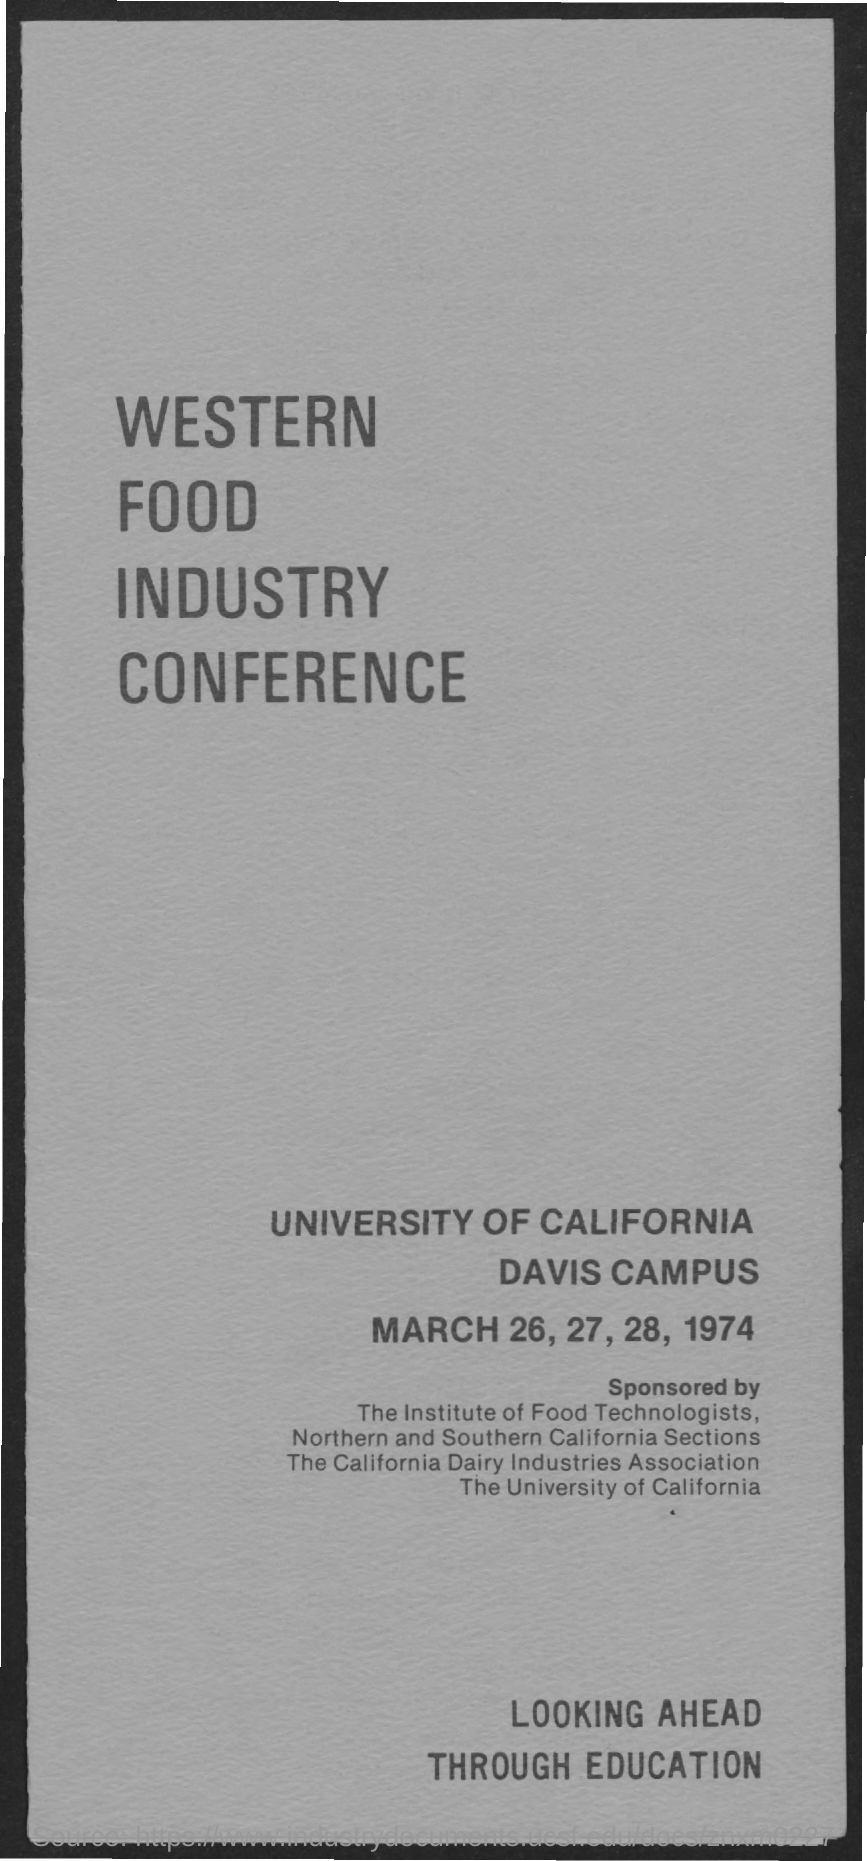Where is the western food industry conference held?
Offer a terse response. UNIVERSITY OF CALIFORNIA, DAVIS CAMPUS. When is the western food industry conference held?
Your response must be concise. March 26, 27, 28, 1974. 